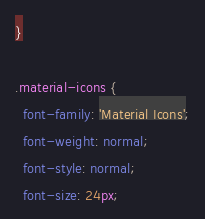Convert code to text. <code><loc_0><loc_0><loc_500><loc_500><_CSS_>}

.material-icons {
  font-family: 'Material Icons';
  font-weight: normal;
  font-style: normal;
  font-size: 24px;</code> 